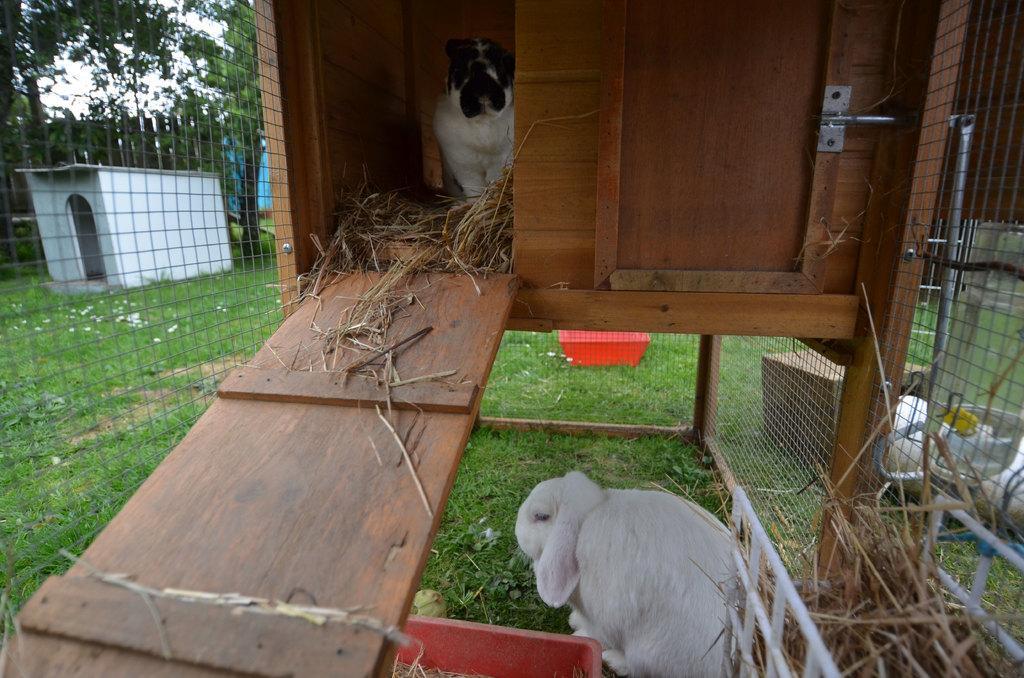Can you describe this image briefly? In this image there are kennels. At the bottom there is a rabbit and we can see grass. There is a dog. On the right we can see a cardboard box and there are bowls. There is a mesh. In the background there are trees and sky. There is a fence. 